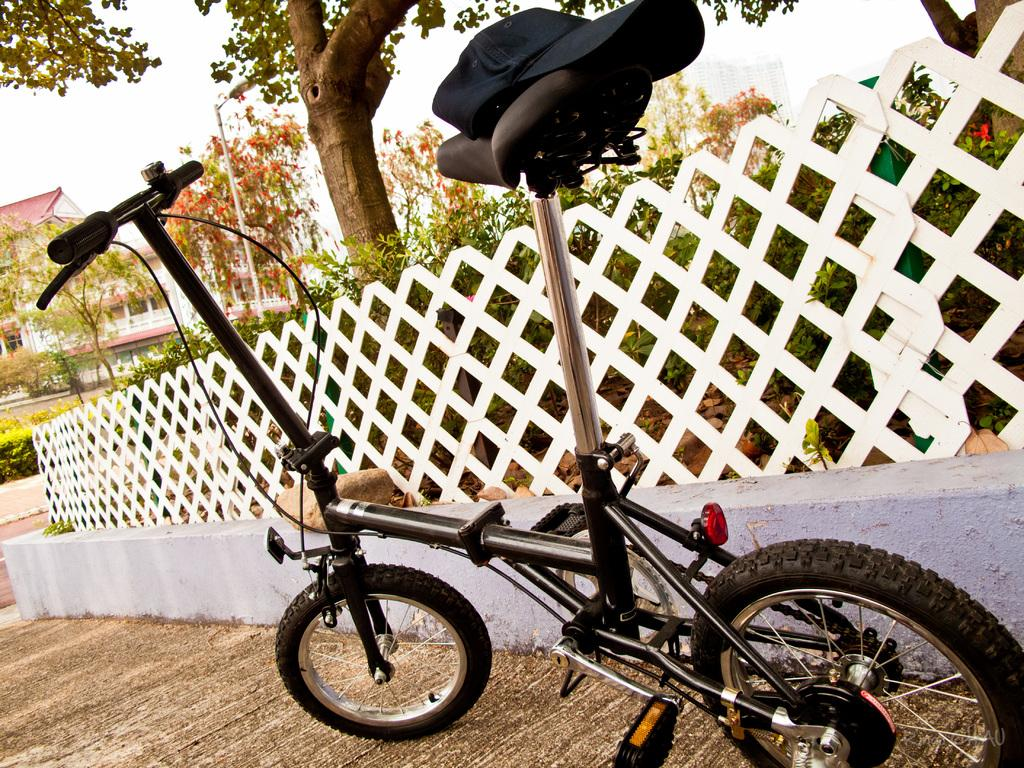What is the main object in the image? There is a bicycle in the image. Where is the bicycle located in relation to other objects? The bicycle is placed next to a fencing wall. What accessory is on the bicycle? A cap is visible on the bicycle. What type of natural elements can be seen in the image? There are trees and plants in the image. What type of man-made structures are present in the image? There are buildings in the image. What degree of curvature can be observed in the grain of the bicycle's frame? There is no mention of grain or curvature in the image, as it features a bicycle, fencing wall, cap, trees, plants, and buildings. 